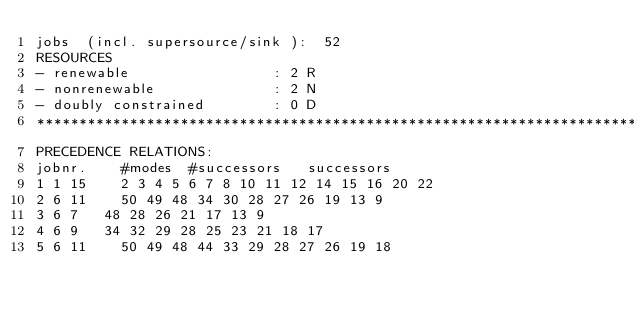<code> <loc_0><loc_0><loc_500><loc_500><_ObjectiveC_>jobs  (incl. supersource/sink ):	52
RESOURCES
- renewable                 : 2 R
- nonrenewable              : 2 N
- doubly constrained        : 0 D
************************************************************************
PRECEDENCE RELATIONS:
jobnr.    #modes  #successors   successors
1	1	15		2 3 4 5 6 7 8 10 11 12 14 15 16 20 22 
2	6	11		50 49 48 34 30 28 27 26 19 13 9 
3	6	7		48 28 26 21 17 13 9 
4	6	9		34 32 29 28 25 23 21 18 17 
5	6	11		50 49 48 44 33 29 28 27 26 19 18 </code> 